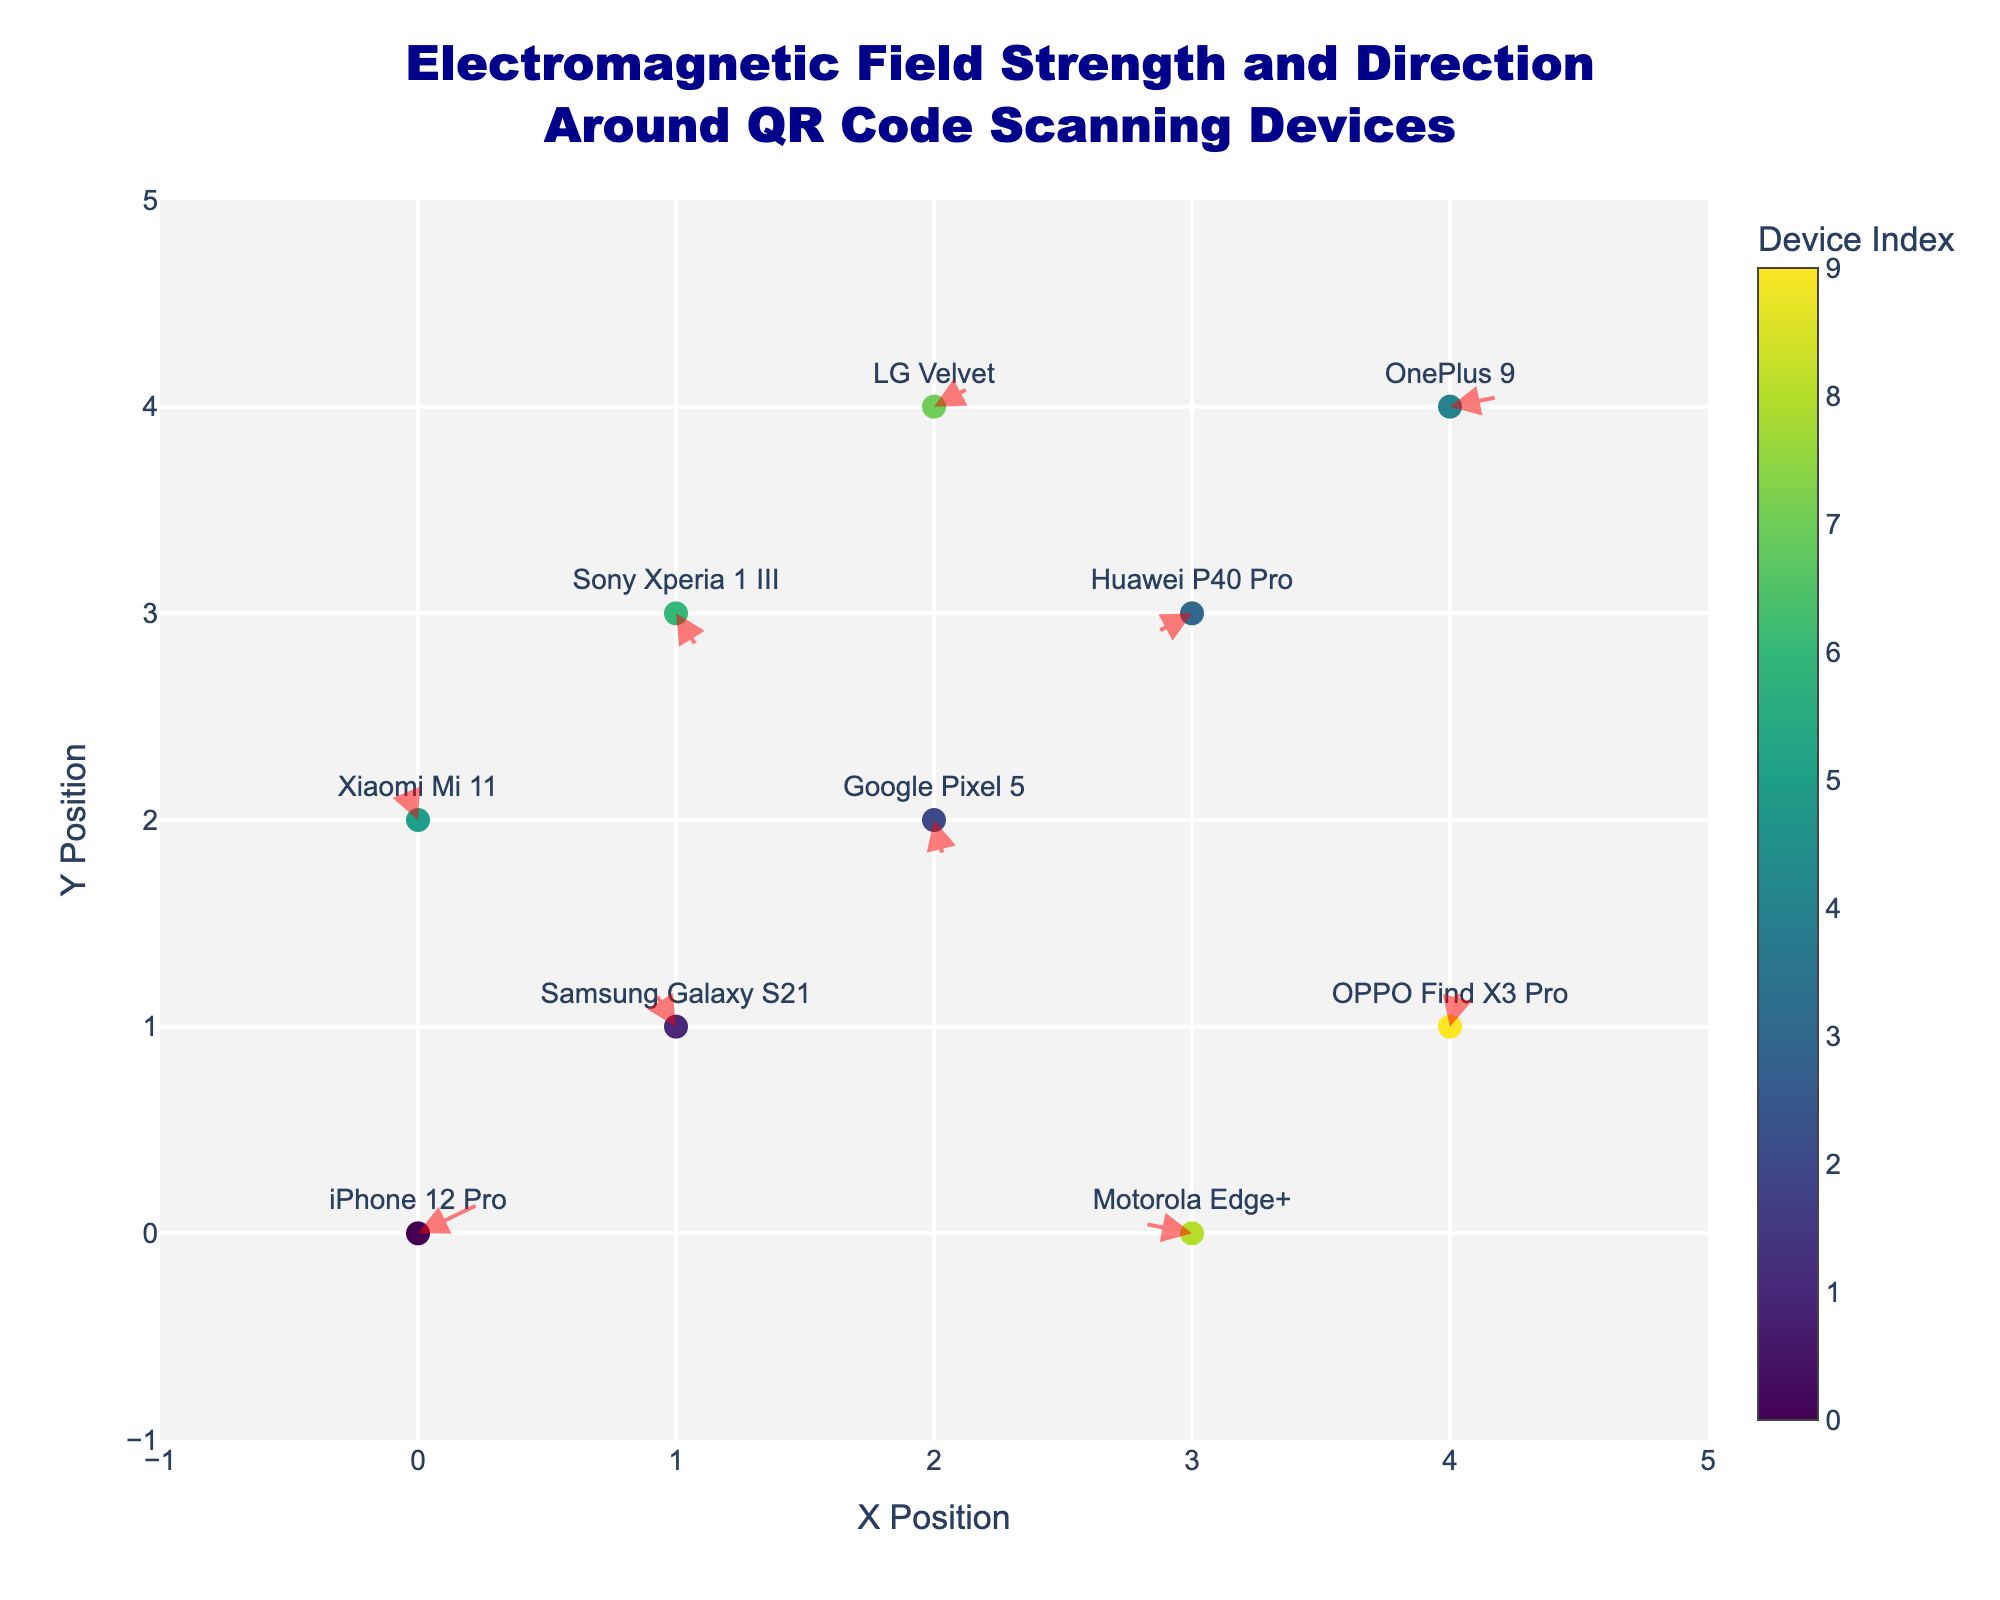What's the title of the plot? The title is located at the top of the plot and gives an overview of the subject being visualized.
Answer: Electromagnetic Field Strength and Direction<br>Around QR Code Scanning Devices How many devices are shown in the plot? Count the number of markers with associated text annotations labeling each device. There are 10 markers on the plot, each representing a unique device.
Answer: 10 Where is the OPPO Find X3 Pro located? Look for the text annotation labeled "OPPO Find X3 Pro" and note its corresponding coordinates on the plot. The coordinates given are (4, 1).
Answer: (4, 1) Which direction does the electromagnetic field for the Huawei P40 Pro point? Find the marker labeled "Huawei P40 Pro" and observe the direction of the arrow originating from it. The arrow points slightly downwards and to the left.
Answer: Downwards left Which device has the strongest electromagnetic field intensity and what direction is it pointing? Our eyes are trained on longer arrows derived from multiplying \( \sqrt{u^2 + v^2} \). The Samsung Galaxy S21 at (1, 1) has the longest arrow, and it points upwards and slightly to the right.
Answer: Samsung Galaxy S21, upwards right Which two devices have opposite electromagnetic field directions? Locate arrows pointing in opposite directions. The LG Velvet at (2, 4) points slightly upwards-right while Huawei P40 Pro at (3, 3) points downwards-left.
Answer: LG Velvet and Huawei P40 Pro Compare the electromagnetic field direction of the iPhone 12 Pro and the Motorola Edge+. Which device's field points more upwards? Check the direction of the arrows for iPhone 12 Pro (0.5, 0.3) and Motorola Edge+ (-0.4, 0.1). The iPhone's arrow points more upwards (higher positive v).
Answer: iPhone 12 Pro What is the average of the horizontal (x) positions for devices with a positive horizontal component (u)? Select devices with positive u, sum their x positions (0+2+4+1+2+4), and divide by their count (6).
Answer: (0+2+4+1+2+4)/6 = 2.17 Which device is at the highest y position? Look at the values on the vertical axis to find the maximum y position. The LG Velvet is at y = 4.
Answer: LG Velvet What is the color theme used for the marker symbols representing the devices? Observe the color range and identify the overall palette used, which varies from dark to light shades.
Answer: Viridis 